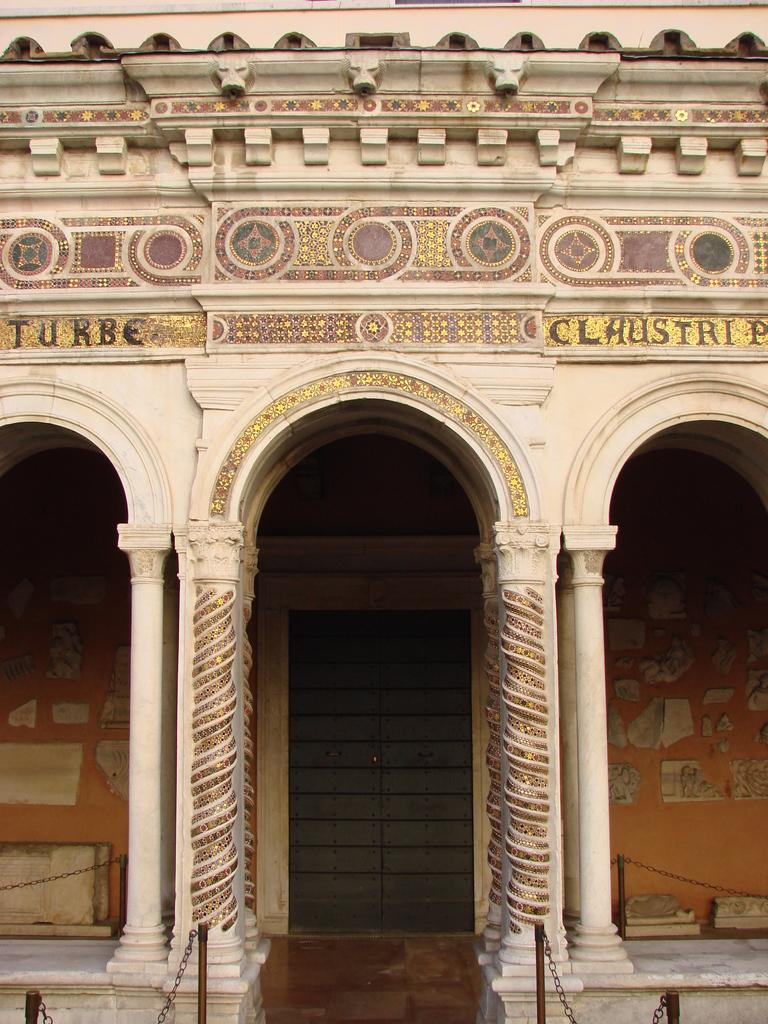What type of structure is visible in the image? There is a building in the image. What artistic element can be seen in the image? There is a sculpture in the image. What architectural feature is present in the image? There are pillars in the image. Where is the entrance to the building located? There is a door at the center of the building. How can one access the upper levels of the building? There are stairs in the image. What type of dirt can be seen on the sculpture in the image? There is no dirt visible on the sculpture in the image. What type of shop is located near the building in the image? There is no shop mentioned or visible in the image. 